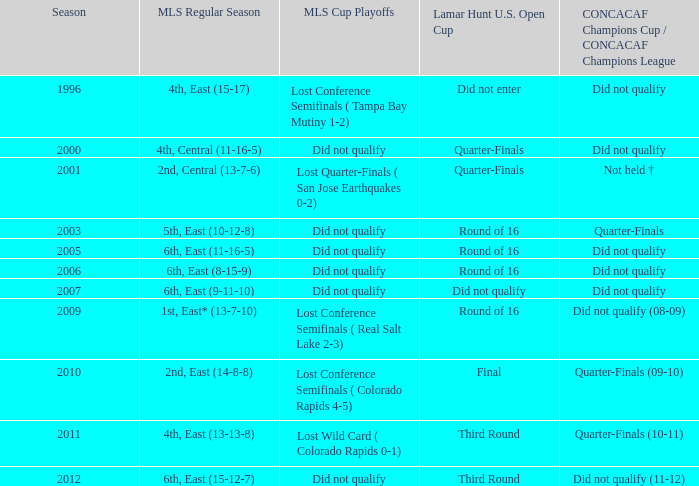When was the mls regular season where the 6th position in the east had a 9-11-10 standing? 2007.0. 